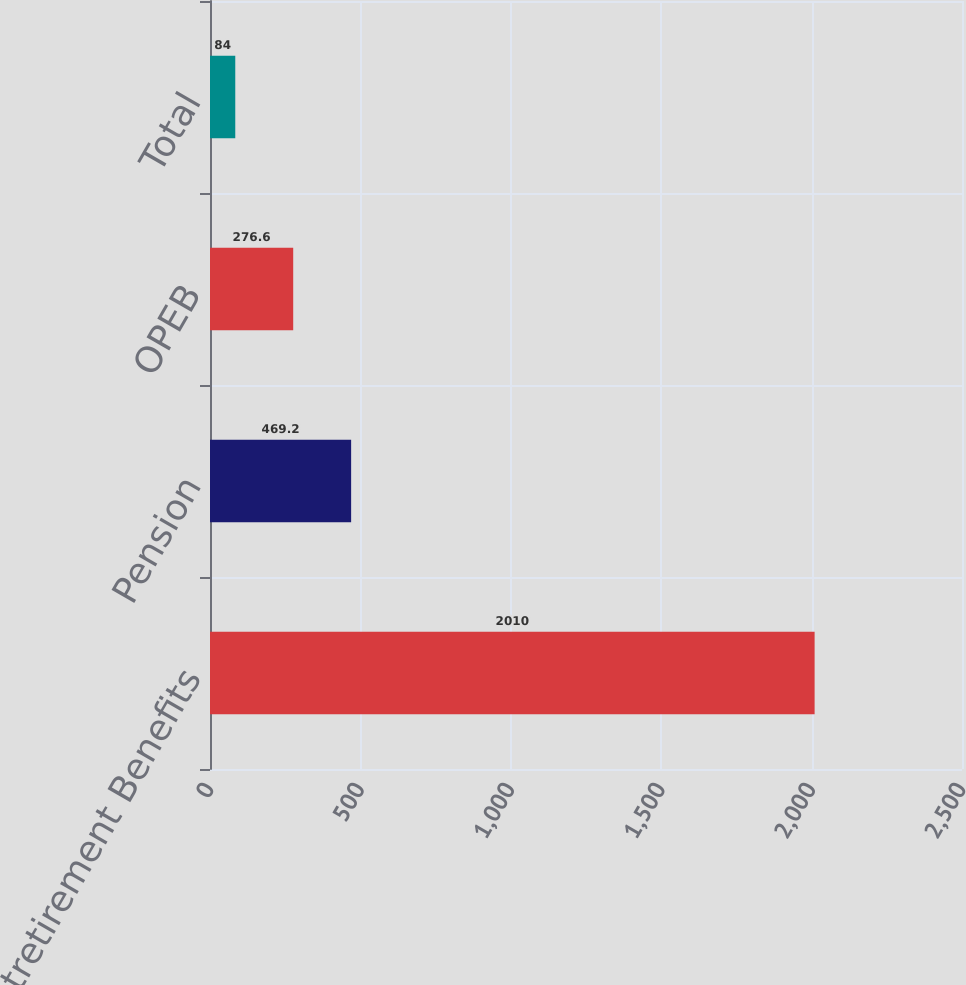Convert chart. <chart><loc_0><loc_0><loc_500><loc_500><bar_chart><fcel>Postretirement Benefits<fcel>Pension<fcel>OPEB<fcel>Total<nl><fcel>2010<fcel>469.2<fcel>276.6<fcel>84<nl></chart> 